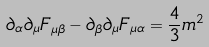Convert formula to latex. <formula><loc_0><loc_0><loc_500><loc_500>\partial _ { \alpha } \partial _ { \mu } F _ { \mu \beta } - \partial _ { \beta } \partial _ { \mu } F _ { \mu \alpha } = \frac { 4 } { 3 } m ^ { 2 }</formula> 